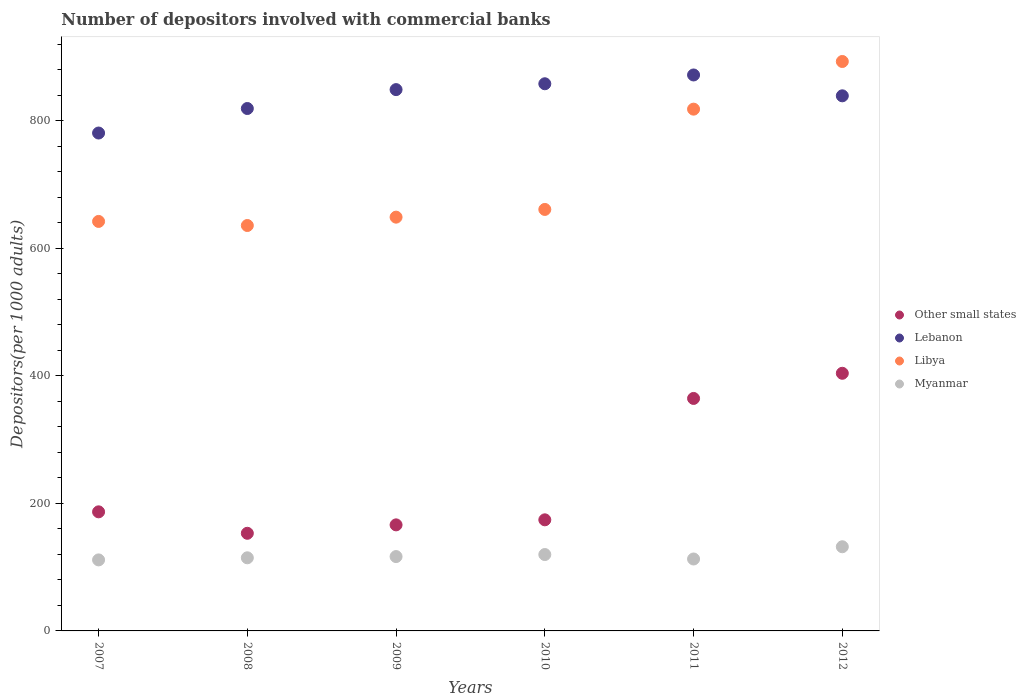How many different coloured dotlines are there?
Your answer should be compact. 4. Is the number of dotlines equal to the number of legend labels?
Ensure brevity in your answer.  Yes. What is the number of depositors involved with commercial banks in Other small states in 2008?
Provide a succinct answer. 153.11. Across all years, what is the maximum number of depositors involved with commercial banks in Libya?
Make the answer very short. 892.96. Across all years, what is the minimum number of depositors involved with commercial banks in Myanmar?
Offer a terse response. 111.37. In which year was the number of depositors involved with commercial banks in Libya minimum?
Make the answer very short. 2008. What is the total number of depositors involved with commercial banks in Other small states in the graph?
Provide a succinct answer. 1448.95. What is the difference between the number of depositors involved with commercial banks in Myanmar in 2009 and that in 2011?
Provide a short and direct response. 3.79. What is the difference between the number of depositors involved with commercial banks in Myanmar in 2012 and the number of depositors involved with commercial banks in Libya in 2010?
Your answer should be very brief. -528.97. What is the average number of depositors involved with commercial banks in Other small states per year?
Give a very brief answer. 241.49. In the year 2010, what is the difference between the number of depositors involved with commercial banks in Libya and number of depositors involved with commercial banks in Lebanon?
Your answer should be compact. -197.08. In how many years, is the number of depositors involved with commercial banks in Lebanon greater than 640?
Your answer should be compact. 6. What is the ratio of the number of depositors involved with commercial banks in Libya in 2007 to that in 2012?
Offer a very short reply. 0.72. Is the number of depositors involved with commercial banks in Myanmar in 2008 less than that in 2009?
Give a very brief answer. Yes. What is the difference between the highest and the second highest number of depositors involved with commercial banks in Other small states?
Your answer should be very brief. 39.45. What is the difference between the highest and the lowest number of depositors involved with commercial banks in Other small states?
Make the answer very short. 250.91. Is the sum of the number of depositors involved with commercial banks in Libya in 2007 and 2009 greater than the maximum number of depositors involved with commercial banks in Other small states across all years?
Provide a succinct answer. Yes. Is it the case that in every year, the sum of the number of depositors involved with commercial banks in Lebanon and number of depositors involved with commercial banks in Libya  is greater than the sum of number of depositors involved with commercial banks in Other small states and number of depositors involved with commercial banks in Myanmar?
Offer a very short reply. No. Is it the case that in every year, the sum of the number of depositors involved with commercial banks in Lebanon and number of depositors involved with commercial banks in Myanmar  is greater than the number of depositors involved with commercial banks in Other small states?
Provide a succinct answer. Yes. Does the number of depositors involved with commercial banks in Myanmar monotonically increase over the years?
Make the answer very short. No. Is the number of depositors involved with commercial banks in Myanmar strictly less than the number of depositors involved with commercial banks in Other small states over the years?
Offer a very short reply. Yes. How many dotlines are there?
Your answer should be very brief. 4. How many years are there in the graph?
Your answer should be compact. 6. Are the values on the major ticks of Y-axis written in scientific E-notation?
Your answer should be very brief. No. Does the graph contain any zero values?
Your answer should be compact. No. Does the graph contain grids?
Your answer should be very brief. No. How are the legend labels stacked?
Make the answer very short. Vertical. What is the title of the graph?
Offer a terse response. Number of depositors involved with commercial banks. What is the label or title of the Y-axis?
Ensure brevity in your answer.  Depositors(per 1000 adults). What is the Depositors(per 1000 adults) of Other small states in 2007?
Your answer should be compact. 186.74. What is the Depositors(per 1000 adults) of Lebanon in 2007?
Keep it short and to the point. 780.78. What is the Depositors(per 1000 adults) of Libya in 2007?
Ensure brevity in your answer.  642.16. What is the Depositors(per 1000 adults) of Myanmar in 2007?
Offer a terse response. 111.37. What is the Depositors(per 1000 adults) of Other small states in 2008?
Provide a short and direct response. 153.11. What is the Depositors(per 1000 adults) of Lebanon in 2008?
Provide a succinct answer. 819.23. What is the Depositors(per 1000 adults) in Libya in 2008?
Keep it short and to the point. 635.76. What is the Depositors(per 1000 adults) of Myanmar in 2008?
Provide a short and direct response. 114.66. What is the Depositors(per 1000 adults) in Other small states in 2009?
Offer a terse response. 166.31. What is the Depositors(per 1000 adults) in Lebanon in 2009?
Ensure brevity in your answer.  848.86. What is the Depositors(per 1000 adults) in Libya in 2009?
Provide a short and direct response. 648.86. What is the Depositors(per 1000 adults) in Myanmar in 2009?
Provide a succinct answer. 116.59. What is the Depositors(per 1000 adults) of Other small states in 2010?
Your answer should be very brief. 174.21. What is the Depositors(per 1000 adults) of Lebanon in 2010?
Keep it short and to the point. 858.04. What is the Depositors(per 1000 adults) of Libya in 2010?
Give a very brief answer. 660.95. What is the Depositors(per 1000 adults) of Myanmar in 2010?
Provide a short and direct response. 119.78. What is the Depositors(per 1000 adults) in Other small states in 2011?
Make the answer very short. 364.57. What is the Depositors(per 1000 adults) in Lebanon in 2011?
Your answer should be compact. 871.83. What is the Depositors(per 1000 adults) of Libya in 2011?
Offer a very short reply. 818.23. What is the Depositors(per 1000 adults) of Myanmar in 2011?
Your answer should be compact. 112.8. What is the Depositors(per 1000 adults) in Other small states in 2012?
Offer a terse response. 404.02. What is the Depositors(per 1000 adults) of Lebanon in 2012?
Give a very brief answer. 839.13. What is the Depositors(per 1000 adults) in Libya in 2012?
Your answer should be very brief. 892.96. What is the Depositors(per 1000 adults) in Myanmar in 2012?
Make the answer very short. 131.99. Across all years, what is the maximum Depositors(per 1000 adults) of Other small states?
Keep it short and to the point. 404.02. Across all years, what is the maximum Depositors(per 1000 adults) of Lebanon?
Your response must be concise. 871.83. Across all years, what is the maximum Depositors(per 1000 adults) in Libya?
Provide a short and direct response. 892.96. Across all years, what is the maximum Depositors(per 1000 adults) in Myanmar?
Make the answer very short. 131.99. Across all years, what is the minimum Depositors(per 1000 adults) of Other small states?
Offer a terse response. 153.11. Across all years, what is the minimum Depositors(per 1000 adults) in Lebanon?
Offer a very short reply. 780.78. Across all years, what is the minimum Depositors(per 1000 adults) in Libya?
Provide a succinct answer. 635.76. Across all years, what is the minimum Depositors(per 1000 adults) of Myanmar?
Keep it short and to the point. 111.37. What is the total Depositors(per 1000 adults) in Other small states in the graph?
Your answer should be very brief. 1448.95. What is the total Depositors(per 1000 adults) in Lebanon in the graph?
Ensure brevity in your answer.  5017.86. What is the total Depositors(per 1000 adults) in Libya in the graph?
Keep it short and to the point. 4298.92. What is the total Depositors(per 1000 adults) in Myanmar in the graph?
Provide a short and direct response. 707.18. What is the difference between the Depositors(per 1000 adults) of Other small states in 2007 and that in 2008?
Keep it short and to the point. 33.63. What is the difference between the Depositors(per 1000 adults) in Lebanon in 2007 and that in 2008?
Offer a very short reply. -38.45. What is the difference between the Depositors(per 1000 adults) of Libya in 2007 and that in 2008?
Keep it short and to the point. 6.4. What is the difference between the Depositors(per 1000 adults) in Myanmar in 2007 and that in 2008?
Your answer should be very brief. -3.3. What is the difference between the Depositors(per 1000 adults) in Other small states in 2007 and that in 2009?
Make the answer very short. 20.43. What is the difference between the Depositors(per 1000 adults) in Lebanon in 2007 and that in 2009?
Give a very brief answer. -68.08. What is the difference between the Depositors(per 1000 adults) in Libya in 2007 and that in 2009?
Your answer should be compact. -6.7. What is the difference between the Depositors(per 1000 adults) of Myanmar in 2007 and that in 2009?
Keep it short and to the point. -5.22. What is the difference between the Depositors(per 1000 adults) in Other small states in 2007 and that in 2010?
Offer a very short reply. 12.53. What is the difference between the Depositors(per 1000 adults) of Lebanon in 2007 and that in 2010?
Your response must be concise. -77.26. What is the difference between the Depositors(per 1000 adults) of Libya in 2007 and that in 2010?
Make the answer very short. -18.8. What is the difference between the Depositors(per 1000 adults) in Myanmar in 2007 and that in 2010?
Give a very brief answer. -8.41. What is the difference between the Depositors(per 1000 adults) in Other small states in 2007 and that in 2011?
Give a very brief answer. -177.83. What is the difference between the Depositors(per 1000 adults) of Lebanon in 2007 and that in 2011?
Make the answer very short. -91.05. What is the difference between the Depositors(per 1000 adults) in Libya in 2007 and that in 2011?
Offer a very short reply. -176.07. What is the difference between the Depositors(per 1000 adults) of Myanmar in 2007 and that in 2011?
Ensure brevity in your answer.  -1.43. What is the difference between the Depositors(per 1000 adults) of Other small states in 2007 and that in 2012?
Provide a succinct answer. -217.28. What is the difference between the Depositors(per 1000 adults) of Lebanon in 2007 and that in 2012?
Make the answer very short. -58.35. What is the difference between the Depositors(per 1000 adults) of Libya in 2007 and that in 2012?
Give a very brief answer. -250.8. What is the difference between the Depositors(per 1000 adults) of Myanmar in 2007 and that in 2012?
Your answer should be compact. -20.62. What is the difference between the Depositors(per 1000 adults) in Other small states in 2008 and that in 2009?
Your answer should be very brief. -13.2. What is the difference between the Depositors(per 1000 adults) in Lebanon in 2008 and that in 2009?
Make the answer very short. -29.63. What is the difference between the Depositors(per 1000 adults) in Libya in 2008 and that in 2009?
Keep it short and to the point. -13.1. What is the difference between the Depositors(per 1000 adults) of Myanmar in 2008 and that in 2009?
Your answer should be very brief. -1.92. What is the difference between the Depositors(per 1000 adults) of Other small states in 2008 and that in 2010?
Provide a short and direct response. -21.11. What is the difference between the Depositors(per 1000 adults) of Lebanon in 2008 and that in 2010?
Ensure brevity in your answer.  -38.81. What is the difference between the Depositors(per 1000 adults) in Libya in 2008 and that in 2010?
Offer a very short reply. -25.19. What is the difference between the Depositors(per 1000 adults) of Myanmar in 2008 and that in 2010?
Your response must be concise. -5.11. What is the difference between the Depositors(per 1000 adults) in Other small states in 2008 and that in 2011?
Your response must be concise. -211.46. What is the difference between the Depositors(per 1000 adults) in Lebanon in 2008 and that in 2011?
Ensure brevity in your answer.  -52.6. What is the difference between the Depositors(per 1000 adults) of Libya in 2008 and that in 2011?
Offer a terse response. -182.47. What is the difference between the Depositors(per 1000 adults) in Myanmar in 2008 and that in 2011?
Offer a very short reply. 1.86. What is the difference between the Depositors(per 1000 adults) of Other small states in 2008 and that in 2012?
Make the answer very short. -250.91. What is the difference between the Depositors(per 1000 adults) of Lebanon in 2008 and that in 2012?
Offer a very short reply. -19.9. What is the difference between the Depositors(per 1000 adults) in Libya in 2008 and that in 2012?
Keep it short and to the point. -257.2. What is the difference between the Depositors(per 1000 adults) in Myanmar in 2008 and that in 2012?
Offer a very short reply. -17.32. What is the difference between the Depositors(per 1000 adults) of Other small states in 2009 and that in 2010?
Make the answer very short. -7.91. What is the difference between the Depositors(per 1000 adults) of Lebanon in 2009 and that in 2010?
Your answer should be very brief. -9.17. What is the difference between the Depositors(per 1000 adults) of Libya in 2009 and that in 2010?
Provide a succinct answer. -12.09. What is the difference between the Depositors(per 1000 adults) of Myanmar in 2009 and that in 2010?
Make the answer very short. -3.19. What is the difference between the Depositors(per 1000 adults) of Other small states in 2009 and that in 2011?
Offer a very short reply. -198.26. What is the difference between the Depositors(per 1000 adults) in Lebanon in 2009 and that in 2011?
Provide a short and direct response. -22.97. What is the difference between the Depositors(per 1000 adults) of Libya in 2009 and that in 2011?
Give a very brief answer. -169.37. What is the difference between the Depositors(per 1000 adults) in Myanmar in 2009 and that in 2011?
Provide a short and direct response. 3.79. What is the difference between the Depositors(per 1000 adults) of Other small states in 2009 and that in 2012?
Your answer should be compact. -237.71. What is the difference between the Depositors(per 1000 adults) of Lebanon in 2009 and that in 2012?
Provide a short and direct response. 9.73. What is the difference between the Depositors(per 1000 adults) in Libya in 2009 and that in 2012?
Offer a terse response. -244.1. What is the difference between the Depositors(per 1000 adults) in Myanmar in 2009 and that in 2012?
Provide a short and direct response. -15.4. What is the difference between the Depositors(per 1000 adults) in Other small states in 2010 and that in 2011?
Offer a very short reply. -190.35. What is the difference between the Depositors(per 1000 adults) in Lebanon in 2010 and that in 2011?
Your response must be concise. -13.79. What is the difference between the Depositors(per 1000 adults) of Libya in 2010 and that in 2011?
Offer a very short reply. -157.27. What is the difference between the Depositors(per 1000 adults) in Myanmar in 2010 and that in 2011?
Make the answer very short. 6.98. What is the difference between the Depositors(per 1000 adults) in Other small states in 2010 and that in 2012?
Ensure brevity in your answer.  -229.8. What is the difference between the Depositors(per 1000 adults) in Lebanon in 2010 and that in 2012?
Your answer should be compact. 18.91. What is the difference between the Depositors(per 1000 adults) in Libya in 2010 and that in 2012?
Your answer should be compact. -232. What is the difference between the Depositors(per 1000 adults) of Myanmar in 2010 and that in 2012?
Offer a terse response. -12.21. What is the difference between the Depositors(per 1000 adults) of Other small states in 2011 and that in 2012?
Make the answer very short. -39.45. What is the difference between the Depositors(per 1000 adults) of Lebanon in 2011 and that in 2012?
Your answer should be very brief. 32.7. What is the difference between the Depositors(per 1000 adults) in Libya in 2011 and that in 2012?
Give a very brief answer. -74.73. What is the difference between the Depositors(per 1000 adults) of Myanmar in 2011 and that in 2012?
Give a very brief answer. -19.19. What is the difference between the Depositors(per 1000 adults) in Other small states in 2007 and the Depositors(per 1000 adults) in Lebanon in 2008?
Your answer should be compact. -632.49. What is the difference between the Depositors(per 1000 adults) of Other small states in 2007 and the Depositors(per 1000 adults) of Libya in 2008?
Your answer should be very brief. -449.02. What is the difference between the Depositors(per 1000 adults) of Other small states in 2007 and the Depositors(per 1000 adults) of Myanmar in 2008?
Give a very brief answer. 72.08. What is the difference between the Depositors(per 1000 adults) of Lebanon in 2007 and the Depositors(per 1000 adults) of Libya in 2008?
Provide a short and direct response. 145.02. What is the difference between the Depositors(per 1000 adults) of Lebanon in 2007 and the Depositors(per 1000 adults) of Myanmar in 2008?
Your answer should be very brief. 666.11. What is the difference between the Depositors(per 1000 adults) in Libya in 2007 and the Depositors(per 1000 adults) in Myanmar in 2008?
Your response must be concise. 527.49. What is the difference between the Depositors(per 1000 adults) in Other small states in 2007 and the Depositors(per 1000 adults) in Lebanon in 2009?
Offer a terse response. -662.12. What is the difference between the Depositors(per 1000 adults) in Other small states in 2007 and the Depositors(per 1000 adults) in Libya in 2009?
Offer a very short reply. -462.12. What is the difference between the Depositors(per 1000 adults) of Other small states in 2007 and the Depositors(per 1000 adults) of Myanmar in 2009?
Provide a short and direct response. 70.15. What is the difference between the Depositors(per 1000 adults) of Lebanon in 2007 and the Depositors(per 1000 adults) of Libya in 2009?
Your answer should be very brief. 131.92. What is the difference between the Depositors(per 1000 adults) of Lebanon in 2007 and the Depositors(per 1000 adults) of Myanmar in 2009?
Your answer should be compact. 664.19. What is the difference between the Depositors(per 1000 adults) of Libya in 2007 and the Depositors(per 1000 adults) of Myanmar in 2009?
Offer a terse response. 525.57. What is the difference between the Depositors(per 1000 adults) in Other small states in 2007 and the Depositors(per 1000 adults) in Lebanon in 2010?
Ensure brevity in your answer.  -671.29. What is the difference between the Depositors(per 1000 adults) in Other small states in 2007 and the Depositors(per 1000 adults) in Libya in 2010?
Your answer should be compact. -474.21. What is the difference between the Depositors(per 1000 adults) of Other small states in 2007 and the Depositors(per 1000 adults) of Myanmar in 2010?
Make the answer very short. 66.96. What is the difference between the Depositors(per 1000 adults) of Lebanon in 2007 and the Depositors(per 1000 adults) of Libya in 2010?
Your answer should be very brief. 119.82. What is the difference between the Depositors(per 1000 adults) of Lebanon in 2007 and the Depositors(per 1000 adults) of Myanmar in 2010?
Provide a succinct answer. 661. What is the difference between the Depositors(per 1000 adults) of Libya in 2007 and the Depositors(per 1000 adults) of Myanmar in 2010?
Make the answer very short. 522.38. What is the difference between the Depositors(per 1000 adults) in Other small states in 2007 and the Depositors(per 1000 adults) in Lebanon in 2011?
Give a very brief answer. -685.09. What is the difference between the Depositors(per 1000 adults) in Other small states in 2007 and the Depositors(per 1000 adults) in Libya in 2011?
Offer a very short reply. -631.49. What is the difference between the Depositors(per 1000 adults) in Other small states in 2007 and the Depositors(per 1000 adults) in Myanmar in 2011?
Offer a terse response. 73.94. What is the difference between the Depositors(per 1000 adults) of Lebanon in 2007 and the Depositors(per 1000 adults) of Libya in 2011?
Provide a succinct answer. -37.45. What is the difference between the Depositors(per 1000 adults) of Lebanon in 2007 and the Depositors(per 1000 adults) of Myanmar in 2011?
Offer a terse response. 667.98. What is the difference between the Depositors(per 1000 adults) of Libya in 2007 and the Depositors(per 1000 adults) of Myanmar in 2011?
Offer a very short reply. 529.36. What is the difference between the Depositors(per 1000 adults) of Other small states in 2007 and the Depositors(per 1000 adults) of Lebanon in 2012?
Ensure brevity in your answer.  -652.39. What is the difference between the Depositors(per 1000 adults) of Other small states in 2007 and the Depositors(per 1000 adults) of Libya in 2012?
Make the answer very short. -706.22. What is the difference between the Depositors(per 1000 adults) of Other small states in 2007 and the Depositors(per 1000 adults) of Myanmar in 2012?
Your answer should be very brief. 54.75. What is the difference between the Depositors(per 1000 adults) in Lebanon in 2007 and the Depositors(per 1000 adults) in Libya in 2012?
Make the answer very short. -112.18. What is the difference between the Depositors(per 1000 adults) of Lebanon in 2007 and the Depositors(per 1000 adults) of Myanmar in 2012?
Your answer should be compact. 648.79. What is the difference between the Depositors(per 1000 adults) of Libya in 2007 and the Depositors(per 1000 adults) of Myanmar in 2012?
Ensure brevity in your answer.  510.17. What is the difference between the Depositors(per 1000 adults) in Other small states in 2008 and the Depositors(per 1000 adults) in Lebanon in 2009?
Your response must be concise. -695.75. What is the difference between the Depositors(per 1000 adults) in Other small states in 2008 and the Depositors(per 1000 adults) in Libya in 2009?
Offer a terse response. -495.75. What is the difference between the Depositors(per 1000 adults) in Other small states in 2008 and the Depositors(per 1000 adults) in Myanmar in 2009?
Give a very brief answer. 36.52. What is the difference between the Depositors(per 1000 adults) of Lebanon in 2008 and the Depositors(per 1000 adults) of Libya in 2009?
Offer a terse response. 170.37. What is the difference between the Depositors(per 1000 adults) in Lebanon in 2008 and the Depositors(per 1000 adults) in Myanmar in 2009?
Your response must be concise. 702.64. What is the difference between the Depositors(per 1000 adults) of Libya in 2008 and the Depositors(per 1000 adults) of Myanmar in 2009?
Your answer should be compact. 519.17. What is the difference between the Depositors(per 1000 adults) of Other small states in 2008 and the Depositors(per 1000 adults) of Lebanon in 2010?
Keep it short and to the point. -704.93. What is the difference between the Depositors(per 1000 adults) of Other small states in 2008 and the Depositors(per 1000 adults) of Libya in 2010?
Make the answer very short. -507.85. What is the difference between the Depositors(per 1000 adults) in Other small states in 2008 and the Depositors(per 1000 adults) in Myanmar in 2010?
Your response must be concise. 33.33. What is the difference between the Depositors(per 1000 adults) of Lebanon in 2008 and the Depositors(per 1000 adults) of Libya in 2010?
Ensure brevity in your answer.  158.27. What is the difference between the Depositors(per 1000 adults) of Lebanon in 2008 and the Depositors(per 1000 adults) of Myanmar in 2010?
Keep it short and to the point. 699.45. What is the difference between the Depositors(per 1000 adults) of Libya in 2008 and the Depositors(per 1000 adults) of Myanmar in 2010?
Offer a terse response. 515.98. What is the difference between the Depositors(per 1000 adults) of Other small states in 2008 and the Depositors(per 1000 adults) of Lebanon in 2011?
Your response must be concise. -718.72. What is the difference between the Depositors(per 1000 adults) in Other small states in 2008 and the Depositors(per 1000 adults) in Libya in 2011?
Provide a short and direct response. -665.12. What is the difference between the Depositors(per 1000 adults) of Other small states in 2008 and the Depositors(per 1000 adults) of Myanmar in 2011?
Provide a short and direct response. 40.31. What is the difference between the Depositors(per 1000 adults) of Lebanon in 2008 and the Depositors(per 1000 adults) of Libya in 2011?
Your answer should be compact. 1. What is the difference between the Depositors(per 1000 adults) of Lebanon in 2008 and the Depositors(per 1000 adults) of Myanmar in 2011?
Your response must be concise. 706.43. What is the difference between the Depositors(per 1000 adults) in Libya in 2008 and the Depositors(per 1000 adults) in Myanmar in 2011?
Your answer should be compact. 522.96. What is the difference between the Depositors(per 1000 adults) in Other small states in 2008 and the Depositors(per 1000 adults) in Lebanon in 2012?
Make the answer very short. -686.02. What is the difference between the Depositors(per 1000 adults) in Other small states in 2008 and the Depositors(per 1000 adults) in Libya in 2012?
Keep it short and to the point. -739.85. What is the difference between the Depositors(per 1000 adults) of Other small states in 2008 and the Depositors(per 1000 adults) of Myanmar in 2012?
Your response must be concise. 21.12. What is the difference between the Depositors(per 1000 adults) in Lebanon in 2008 and the Depositors(per 1000 adults) in Libya in 2012?
Offer a terse response. -73.73. What is the difference between the Depositors(per 1000 adults) of Lebanon in 2008 and the Depositors(per 1000 adults) of Myanmar in 2012?
Your answer should be very brief. 687.24. What is the difference between the Depositors(per 1000 adults) of Libya in 2008 and the Depositors(per 1000 adults) of Myanmar in 2012?
Give a very brief answer. 503.77. What is the difference between the Depositors(per 1000 adults) of Other small states in 2009 and the Depositors(per 1000 adults) of Lebanon in 2010?
Your response must be concise. -691.73. What is the difference between the Depositors(per 1000 adults) in Other small states in 2009 and the Depositors(per 1000 adults) in Libya in 2010?
Keep it short and to the point. -494.65. What is the difference between the Depositors(per 1000 adults) in Other small states in 2009 and the Depositors(per 1000 adults) in Myanmar in 2010?
Offer a very short reply. 46.53. What is the difference between the Depositors(per 1000 adults) in Lebanon in 2009 and the Depositors(per 1000 adults) in Libya in 2010?
Provide a short and direct response. 187.91. What is the difference between the Depositors(per 1000 adults) of Lebanon in 2009 and the Depositors(per 1000 adults) of Myanmar in 2010?
Offer a terse response. 729.08. What is the difference between the Depositors(per 1000 adults) of Libya in 2009 and the Depositors(per 1000 adults) of Myanmar in 2010?
Ensure brevity in your answer.  529.08. What is the difference between the Depositors(per 1000 adults) in Other small states in 2009 and the Depositors(per 1000 adults) in Lebanon in 2011?
Offer a terse response. -705.52. What is the difference between the Depositors(per 1000 adults) in Other small states in 2009 and the Depositors(per 1000 adults) in Libya in 2011?
Your response must be concise. -651.92. What is the difference between the Depositors(per 1000 adults) in Other small states in 2009 and the Depositors(per 1000 adults) in Myanmar in 2011?
Provide a succinct answer. 53.51. What is the difference between the Depositors(per 1000 adults) of Lebanon in 2009 and the Depositors(per 1000 adults) of Libya in 2011?
Provide a short and direct response. 30.63. What is the difference between the Depositors(per 1000 adults) in Lebanon in 2009 and the Depositors(per 1000 adults) in Myanmar in 2011?
Your answer should be very brief. 736.06. What is the difference between the Depositors(per 1000 adults) of Libya in 2009 and the Depositors(per 1000 adults) of Myanmar in 2011?
Keep it short and to the point. 536.06. What is the difference between the Depositors(per 1000 adults) of Other small states in 2009 and the Depositors(per 1000 adults) of Lebanon in 2012?
Your answer should be very brief. -672.82. What is the difference between the Depositors(per 1000 adults) in Other small states in 2009 and the Depositors(per 1000 adults) in Libya in 2012?
Your answer should be compact. -726.65. What is the difference between the Depositors(per 1000 adults) of Other small states in 2009 and the Depositors(per 1000 adults) of Myanmar in 2012?
Keep it short and to the point. 34.32. What is the difference between the Depositors(per 1000 adults) of Lebanon in 2009 and the Depositors(per 1000 adults) of Libya in 2012?
Keep it short and to the point. -44.1. What is the difference between the Depositors(per 1000 adults) of Lebanon in 2009 and the Depositors(per 1000 adults) of Myanmar in 2012?
Your response must be concise. 716.87. What is the difference between the Depositors(per 1000 adults) in Libya in 2009 and the Depositors(per 1000 adults) in Myanmar in 2012?
Your response must be concise. 516.87. What is the difference between the Depositors(per 1000 adults) in Other small states in 2010 and the Depositors(per 1000 adults) in Lebanon in 2011?
Your response must be concise. -697.62. What is the difference between the Depositors(per 1000 adults) of Other small states in 2010 and the Depositors(per 1000 adults) of Libya in 2011?
Keep it short and to the point. -644.02. What is the difference between the Depositors(per 1000 adults) in Other small states in 2010 and the Depositors(per 1000 adults) in Myanmar in 2011?
Make the answer very short. 61.41. What is the difference between the Depositors(per 1000 adults) in Lebanon in 2010 and the Depositors(per 1000 adults) in Libya in 2011?
Provide a succinct answer. 39.81. What is the difference between the Depositors(per 1000 adults) in Lebanon in 2010 and the Depositors(per 1000 adults) in Myanmar in 2011?
Keep it short and to the point. 745.24. What is the difference between the Depositors(per 1000 adults) in Libya in 2010 and the Depositors(per 1000 adults) in Myanmar in 2011?
Ensure brevity in your answer.  548.15. What is the difference between the Depositors(per 1000 adults) of Other small states in 2010 and the Depositors(per 1000 adults) of Lebanon in 2012?
Provide a short and direct response. -664.91. What is the difference between the Depositors(per 1000 adults) in Other small states in 2010 and the Depositors(per 1000 adults) in Libya in 2012?
Give a very brief answer. -718.74. What is the difference between the Depositors(per 1000 adults) in Other small states in 2010 and the Depositors(per 1000 adults) in Myanmar in 2012?
Provide a short and direct response. 42.23. What is the difference between the Depositors(per 1000 adults) in Lebanon in 2010 and the Depositors(per 1000 adults) in Libya in 2012?
Provide a succinct answer. -34.92. What is the difference between the Depositors(per 1000 adults) in Lebanon in 2010 and the Depositors(per 1000 adults) in Myanmar in 2012?
Make the answer very short. 726.05. What is the difference between the Depositors(per 1000 adults) in Libya in 2010 and the Depositors(per 1000 adults) in Myanmar in 2012?
Make the answer very short. 528.97. What is the difference between the Depositors(per 1000 adults) of Other small states in 2011 and the Depositors(per 1000 adults) of Lebanon in 2012?
Offer a terse response. -474.56. What is the difference between the Depositors(per 1000 adults) in Other small states in 2011 and the Depositors(per 1000 adults) in Libya in 2012?
Provide a short and direct response. -528.39. What is the difference between the Depositors(per 1000 adults) of Other small states in 2011 and the Depositors(per 1000 adults) of Myanmar in 2012?
Ensure brevity in your answer.  232.58. What is the difference between the Depositors(per 1000 adults) of Lebanon in 2011 and the Depositors(per 1000 adults) of Libya in 2012?
Offer a very short reply. -21.13. What is the difference between the Depositors(per 1000 adults) in Lebanon in 2011 and the Depositors(per 1000 adults) in Myanmar in 2012?
Give a very brief answer. 739.84. What is the difference between the Depositors(per 1000 adults) in Libya in 2011 and the Depositors(per 1000 adults) in Myanmar in 2012?
Give a very brief answer. 686.24. What is the average Depositors(per 1000 adults) in Other small states per year?
Give a very brief answer. 241.49. What is the average Depositors(per 1000 adults) in Lebanon per year?
Provide a succinct answer. 836.31. What is the average Depositors(per 1000 adults) of Libya per year?
Make the answer very short. 716.49. What is the average Depositors(per 1000 adults) in Myanmar per year?
Provide a succinct answer. 117.86. In the year 2007, what is the difference between the Depositors(per 1000 adults) in Other small states and Depositors(per 1000 adults) in Lebanon?
Provide a short and direct response. -594.04. In the year 2007, what is the difference between the Depositors(per 1000 adults) of Other small states and Depositors(per 1000 adults) of Libya?
Your answer should be compact. -455.42. In the year 2007, what is the difference between the Depositors(per 1000 adults) in Other small states and Depositors(per 1000 adults) in Myanmar?
Your answer should be very brief. 75.37. In the year 2007, what is the difference between the Depositors(per 1000 adults) in Lebanon and Depositors(per 1000 adults) in Libya?
Your answer should be very brief. 138.62. In the year 2007, what is the difference between the Depositors(per 1000 adults) in Lebanon and Depositors(per 1000 adults) in Myanmar?
Give a very brief answer. 669.41. In the year 2007, what is the difference between the Depositors(per 1000 adults) in Libya and Depositors(per 1000 adults) in Myanmar?
Make the answer very short. 530.79. In the year 2008, what is the difference between the Depositors(per 1000 adults) in Other small states and Depositors(per 1000 adults) in Lebanon?
Offer a very short reply. -666.12. In the year 2008, what is the difference between the Depositors(per 1000 adults) in Other small states and Depositors(per 1000 adults) in Libya?
Make the answer very short. -482.65. In the year 2008, what is the difference between the Depositors(per 1000 adults) in Other small states and Depositors(per 1000 adults) in Myanmar?
Your answer should be compact. 38.44. In the year 2008, what is the difference between the Depositors(per 1000 adults) in Lebanon and Depositors(per 1000 adults) in Libya?
Your answer should be compact. 183.47. In the year 2008, what is the difference between the Depositors(per 1000 adults) in Lebanon and Depositors(per 1000 adults) in Myanmar?
Your answer should be very brief. 704.56. In the year 2008, what is the difference between the Depositors(per 1000 adults) in Libya and Depositors(per 1000 adults) in Myanmar?
Provide a succinct answer. 521.1. In the year 2009, what is the difference between the Depositors(per 1000 adults) in Other small states and Depositors(per 1000 adults) in Lebanon?
Your response must be concise. -682.55. In the year 2009, what is the difference between the Depositors(per 1000 adults) in Other small states and Depositors(per 1000 adults) in Libya?
Offer a terse response. -482.55. In the year 2009, what is the difference between the Depositors(per 1000 adults) in Other small states and Depositors(per 1000 adults) in Myanmar?
Offer a very short reply. 49.72. In the year 2009, what is the difference between the Depositors(per 1000 adults) in Lebanon and Depositors(per 1000 adults) in Libya?
Keep it short and to the point. 200. In the year 2009, what is the difference between the Depositors(per 1000 adults) of Lebanon and Depositors(per 1000 adults) of Myanmar?
Provide a succinct answer. 732.27. In the year 2009, what is the difference between the Depositors(per 1000 adults) in Libya and Depositors(per 1000 adults) in Myanmar?
Provide a short and direct response. 532.27. In the year 2010, what is the difference between the Depositors(per 1000 adults) in Other small states and Depositors(per 1000 adults) in Lebanon?
Your response must be concise. -683.82. In the year 2010, what is the difference between the Depositors(per 1000 adults) of Other small states and Depositors(per 1000 adults) of Libya?
Your answer should be very brief. -486.74. In the year 2010, what is the difference between the Depositors(per 1000 adults) in Other small states and Depositors(per 1000 adults) in Myanmar?
Your answer should be very brief. 54.43. In the year 2010, what is the difference between the Depositors(per 1000 adults) of Lebanon and Depositors(per 1000 adults) of Libya?
Offer a very short reply. 197.08. In the year 2010, what is the difference between the Depositors(per 1000 adults) in Lebanon and Depositors(per 1000 adults) in Myanmar?
Keep it short and to the point. 738.26. In the year 2010, what is the difference between the Depositors(per 1000 adults) in Libya and Depositors(per 1000 adults) in Myanmar?
Your response must be concise. 541.18. In the year 2011, what is the difference between the Depositors(per 1000 adults) in Other small states and Depositors(per 1000 adults) in Lebanon?
Your answer should be very brief. -507.26. In the year 2011, what is the difference between the Depositors(per 1000 adults) in Other small states and Depositors(per 1000 adults) in Libya?
Your answer should be very brief. -453.66. In the year 2011, what is the difference between the Depositors(per 1000 adults) of Other small states and Depositors(per 1000 adults) of Myanmar?
Ensure brevity in your answer.  251.77. In the year 2011, what is the difference between the Depositors(per 1000 adults) in Lebanon and Depositors(per 1000 adults) in Libya?
Your answer should be compact. 53.6. In the year 2011, what is the difference between the Depositors(per 1000 adults) in Lebanon and Depositors(per 1000 adults) in Myanmar?
Offer a terse response. 759.03. In the year 2011, what is the difference between the Depositors(per 1000 adults) of Libya and Depositors(per 1000 adults) of Myanmar?
Offer a terse response. 705.43. In the year 2012, what is the difference between the Depositors(per 1000 adults) of Other small states and Depositors(per 1000 adults) of Lebanon?
Offer a very short reply. -435.11. In the year 2012, what is the difference between the Depositors(per 1000 adults) of Other small states and Depositors(per 1000 adults) of Libya?
Give a very brief answer. -488.94. In the year 2012, what is the difference between the Depositors(per 1000 adults) in Other small states and Depositors(per 1000 adults) in Myanmar?
Give a very brief answer. 272.03. In the year 2012, what is the difference between the Depositors(per 1000 adults) of Lebanon and Depositors(per 1000 adults) of Libya?
Provide a short and direct response. -53.83. In the year 2012, what is the difference between the Depositors(per 1000 adults) of Lebanon and Depositors(per 1000 adults) of Myanmar?
Your response must be concise. 707.14. In the year 2012, what is the difference between the Depositors(per 1000 adults) of Libya and Depositors(per 1000 adults) of Myanmar?
Offer a very short reply. 760.97. What is the ratio of the Depositors(per 1000 adults) in Other small states in 2007 to that in 2008?
Offer a terse response. 1.22. What is the ratio of the Depositors(per 1000 adults) in Lebanon in 2007 to that in 2008?
Your answer should be compact. 0.95. What is the ratio of the Depositors(per 1000 adults) in Libya in 2007 to that in 2008?
Make the answer very short. 1.01. What is the ratio of the Depositors(per 1000 adults) in Myanmar in 2007 to that in 2008?
Ensure brevity in your answer.  0.97. What is the ratio of the Depositors(per 1000 adults) in Other small states in 2007 to that in 2009?
Ensure brevity in your answer.  1.12. What is the ratio of the Depositors(per 1000 adults) in Lebanon in 2007 to that in 2009?
Your answer should be very brief. 0.92. What is the ratio of the Depositors(per 1000 adults) in Libya in 2007 to that in 2009?
Your response must be concise. 0.99. What is the ratio of the Depositors(per 1000 adults) in Myanmar in 2007 to that in 2009?
Your answer should be very brief. 0.96. What is the ratio of the Depositors(per 1000 adults) in Other small states in 2007 to that in 2010?
Your answer should be very brief. 1.07. What is the ratio of the Depositors(per 1000 adults) in Lebanon in 2007 to that in 2010?
Make the answer very short. 0.91. What is the ratio of the Depositors(per 1000 adults) of Libya in 2007 to that in 2010?
Your answer should be compact. 0.97. What is the ratio of the Depositors(per 1000 adults) in Myanmar in 2007 to that in 2010?
Your answer should be compact. 0.93. What is the ratio of the Depositors(per 1000 adults) in Other small states in 2007 to that in 2011?
Provide a short and direct response. 0.51. What is the ratio of the Depositors(per 1000 adults) of Lebanon in 2007 to that in 2011?
Give a very brief answer. 0.9. What is the ratio of the Depositors(per 1000 adults) in Libya in 2007 to that in 2011?
Offer a very short reply. 0.78. What is the ratio of the Depositors(per 1000 adults) of Myanmar in 2007 to that in 2011?
Your answer should be very brief. 0.99. What is the ratio of the Depositors(per 1000 adults) in Other small states in 2007 to that in 2012?
Keep it short and to the point. 0.46. What is the ratio of the Depositors(per 1000 adults) in Lebanon in 2007 to that in 2012?
Offer a terse response. 0.93. What is the ratio of the Depositors(per 1000 adults) of Libya in 2007 to that in 2012?
Make the answer very short. 0.72. What is the ratio of the Depositors(per 1000 adults) in Myanmar in 2007 to that in 2012?
Provide a short and direct response. 0.84. What is the ratio of the Depositors(per 1000 adults) of Other small states in 2008 to that in 2009?
Give a very brief answer. 0.92. What is the ratio of the Depositors(per 1000 adults) of Lebanon in 2008 to that in 2009?
Provide a succinct answer. 0.97. What is the ratio of the Depositors(per 1000 adults) in Libya in 2008 to that in 2009?
Your response must be concise. 0.98. What is the ratio of the Depositors(per 1000 adults) of Myanmar in 2008 to that in 2009?
Make the answer very short. 0.98. What is the ratio of the Depositors(per 1000 adults) in Other small states in 2008 to that in 2010?
Your answer should be compact. 0.88. What is the ratio of the Depositors(per 1000 adults) in Lebanon in 2008 to that in 2010?
Ensure brevity in your answer.  0.95. What is the ratio of the Depositors(per 1000 adults) of Libya in 2008 to that in 2010?
Offer a very short reply. 0.96. What is the ratio of the Depositors(per 1000 adults) in Myanmar in 2008 to that in 2010?
Offer a terse response. 0.96. What is the ratio of the Depositors(per 1000 adults) of Other small states in 2008 to that in 2011?
Keep it short and to the point. 0.42. What is the ratio of the Depositors(per 1000 adults) in Lebanon in 2008 to that in 2011?
Provide a short and direct response. 0.94. What is the ratio of the Depositors(per 1000 adults) of Libya in 2008 to that in 2011?
Offer a terse response. 0.78. What is the ratio of the Depositors(per 1000 adults) of Myanmar in 2008 to that in 2011?
Offer a terse response. 1.02. What is the ratio of the Depositors(per 1000 adults) of Other small states in 2008 to that in 2012?
Provide a short and direct response. 0.38. What is the ratio of the Depositors(per 1000 adults) in Lebanon in 2008 to that in 2012?
Provide a succinct answer. 0.98. What is the ratio of the Depositors(per 1000 adults) of Libya in 2008 to that in 2012?
Provide a short and direct response. 0.71. What is the ratio of the Depositors(per 1000 adults) in Myanmar in 2008 to that in 2012?
Provide a succinct answer. 0.87. What is the ratio of the Depositors(per 1000 adults) of Other small states in 2009 to that in 2010?
Ensure brevity in your answer.  0.95. What is the ratio of the Depositors(per 1000 adults) of Lebanon in 2009 to that in 2010?
Provide a short and direct response. 0.99. What is the ratio of the Depositors(per 1000 adults) in Libya in 2009 to that in 2010?
Provide a succinct answer. 0.98. What is the ratio of the Depositors(per 1000 adults) in Myanmar in 2009 to that in 2010?
Offer a terse response. 0.97. What is the ratio of the Depositors(per 1000 adults) in Other small states in 2009 to that in 2011?
Make the answer very short. 0.46. What is the ratio of the Depositors(per 1000 adults) in Lebanon in 2009 to that in 2011?
Your answer should be compact. 0.97. What is the ratio of the Depositors(per 1000 adults) in Libya in 2009 to that in 2011?
Ensure brevity in your answer.  0.79. What is the ratio of the Depositors(per 1000 adults) in Myanmar in 2009 to that in 2011?
Offer a very short reply. 1.03. What is the ratio of the Depositors(per 1000 adults) of Other small states in 2009 to that in 2012?
Your response must be concise. 0.41. What is the ratio of the Depositors(per 1000 adults) of Lebanon in 2009 to that in 2012?
Your answer should be compact. 1.01. What is the ratio of the Depositors(per 1000 adults) of Libya in 2009 to that in 2012?
Offer a terse response. 0.73. What is the ratio of the Depositors(per 1000 adults) of Myanmar in 2009 to that in 2012?
Your response must be concise. 0.88. What is the ratio of the Depositors(per 1000 adults) of Other small states in 2010 to that in 2011?
Ensure brevity in your answer.  0.48. What is the ratio of the Depositors(per 1000 adults) of Lebanon in 2010 to that in 2011?
Make the answer very short. 0.98. What is the ratio of the Depositors(per 1000 adults) of Libya in 2010 to that in 2011?
Provide a short and direct response. 0.81. What is the ratio of the Depositors(per 1000 adults) in Myanmar in 2010 to that in 2011?
Your response must be concise. 1.06. What is the ratio of the Depositors(per 1000 adults) of Other small states in 2010 to that in 2012?
Keep it short and to the point. 0.43. What is the ratio of the Depositors(per 1000 adults) in Lebanon in 2010 to that in 2012?
Make the answer very short. 1.02. What is the ratio of the Depositors(per 1000 adults) of Libya in 2010 to that in 2012?
Offer a very short reply. 0.74. What is the ratio of the Depositors(per 1000 adults) in Myanmar in 2010 to that in 2012?
Make the answer very short. 0.91. What is the ratio of the Depositors(per 1000 adults) in Other small states in 2011 to that in 2012?
Provide a succinct answer. 0.9. What is the ratio of the Depositors(per 1000 adults) of Lebanon in 2011 to that in 2012?
Provide a short and direct response. 1.04. What is the ratio of the Depositors(per 1000 adults) in Libya in 2011 to that in 2012?
Make the answer very short. 0.92. What is the ratio of the Depositors(per 1000 adults) of Myanmar in 2011 to that in 2012?
Offer a terse response. 0.85. What is the difference between the highest and the second highest Depositors(per 1000 adults) of Other small states?
Offer a very short reply. 39.45. What is the difference between the highest and the second highest Depositors(per 1000 adults) of Lebanon?
Your answer should be compact. 13.79. What is the difference between the highest and the second highest Depositors(per 1000 adults) in Libya?
Give a very brief answer. 74.73. What is the difference between the highest and the second highest Depositors(per 1000 adults) in Myanmar?
Ensure brevity in your answer.  12.21. What is the difference between the highest and the lowest Depositors(per 1000 adults) of Other small states?
Make the answer very short. 250.91. What is the difference between the highest and the lowest Depositors(per 1000 adults) of Lebanon?
Your response must be concise. 91.05. What is the difference between the highest and the lowest Depositors(per 1000 adults) of Libya?
Provide a short and direct response. 257.2. What is the difference between the highest and the lowest Depositors(per 1000 adults) in Myanmar?
Keep it short and to the point. 20.62. 